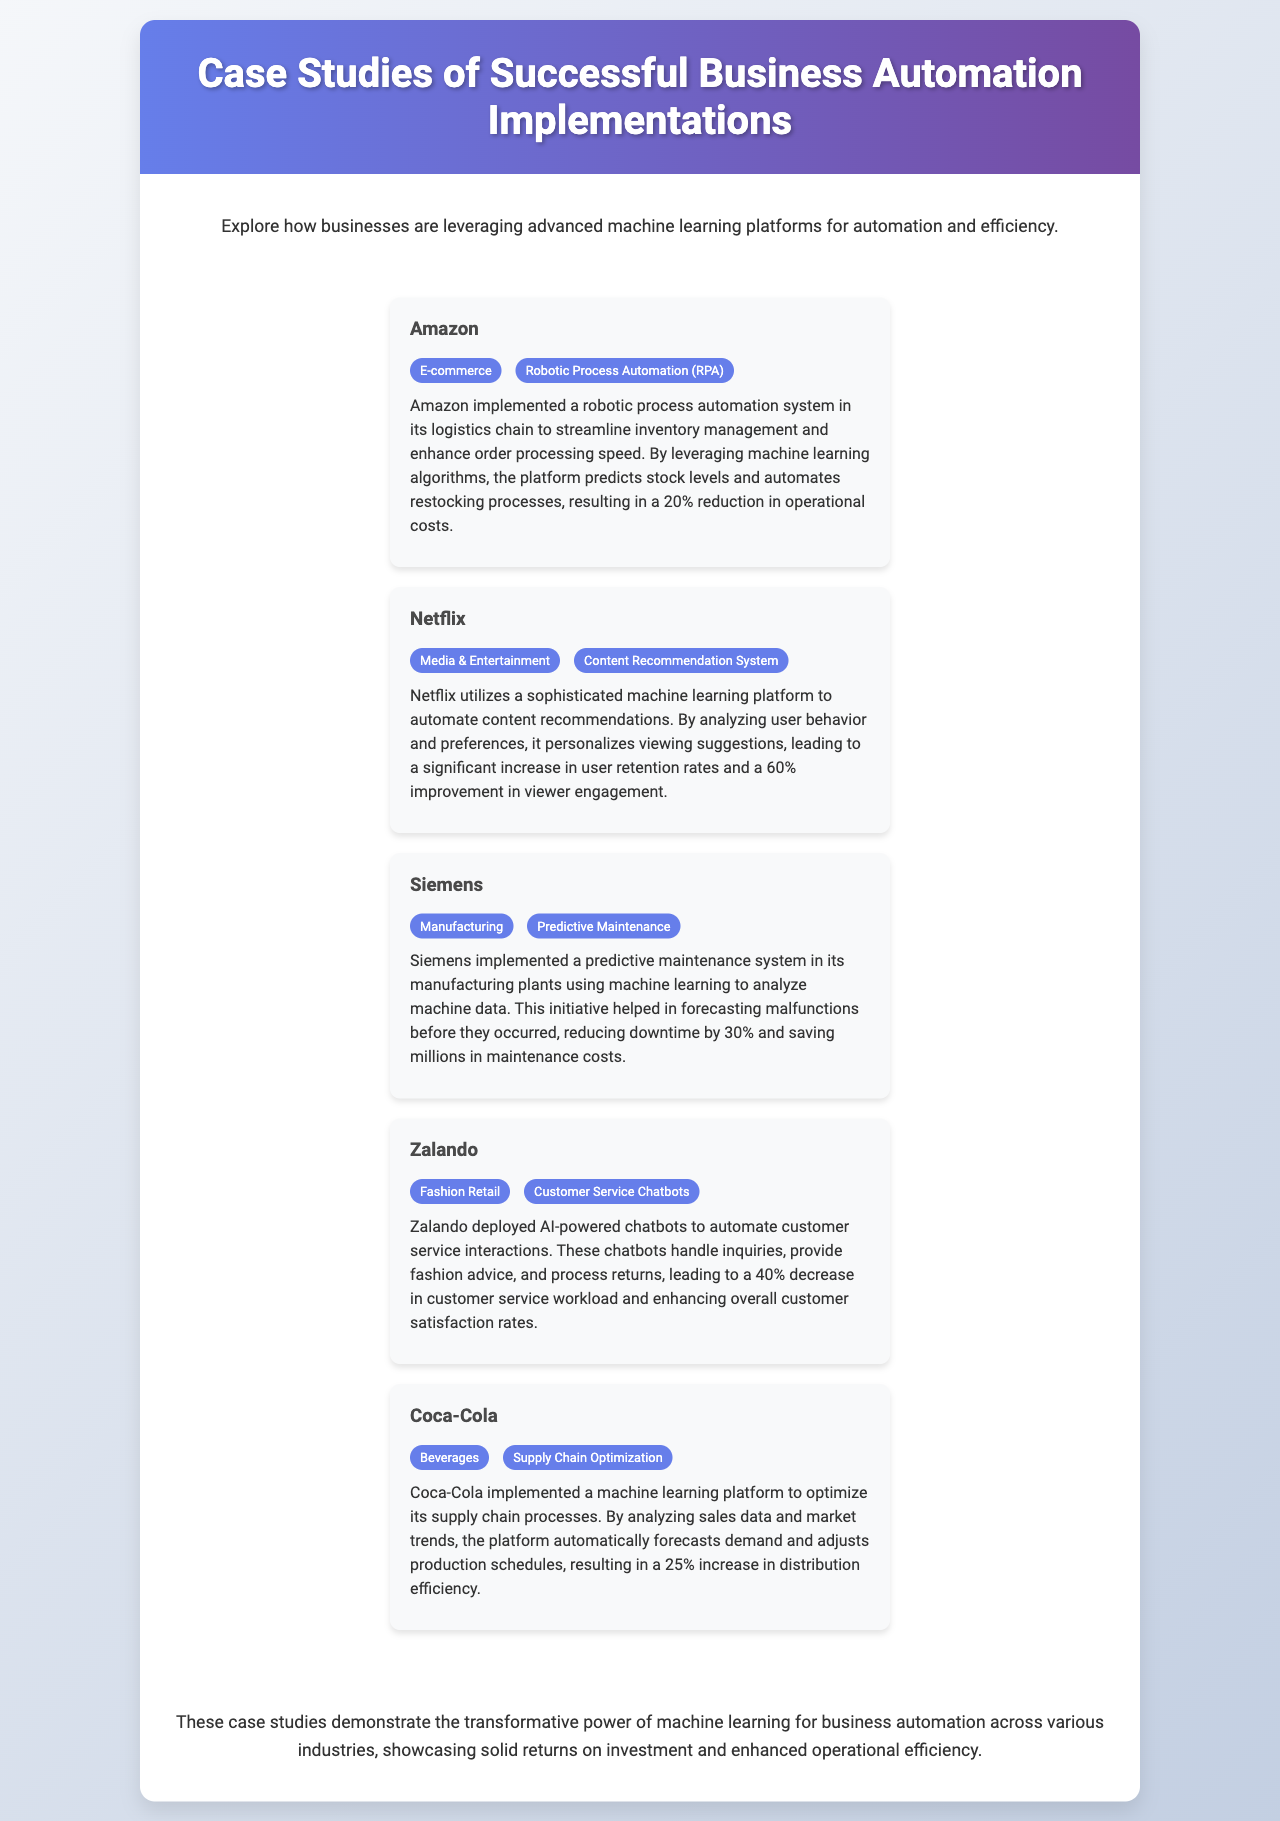What business implemented robotic process automation? The document mentions Amazon as having implemented a robotic process automation system in its logistics chain.
Answer: Amazon How much did Amazon reduce its operational costs by? Amazon's implementation of RPA resulted in a 20% reduction in operational costs.
Answer: 20% What type of system does Netflix utilize for content recommendations? The brochure specifies that Netflix uses a content recommendation system for personalizing viewing suggestions.
Answer: Content Recommendation System By what percentage did Siemens reduce downtime? Siemens forecasts malfunctions, resulting in a reported reduction of 30% in downtime.
Answer: 30% What technology did Zalando use to automate customer service? Zalando deployed AI-powered chatbots for automating customer service interactions.
Answer: Chatbots What was the outcome of Coca-Cola's supply chain optimization implementation? The machine learning platform implemented by Coca-Cola resulted in a 25% increase in distribution efficiency.
Answer: 25% Which company focused on predictive maintenance in manufacturing? The document indicates that Siemens focused on predictive maintenance in its manufacturing plants.
Answer: Siemens How did Netflix improve viewer engagement? The document states that Netflix improved viewer engagement through personalized viewing suggestions, leading to a 60% improvement.
Answer: 60% What industry does Coca-Cola belong to? Coca-Cola is categorized under the beverages industry as per the brochure's listings.
Answer: Beverages 